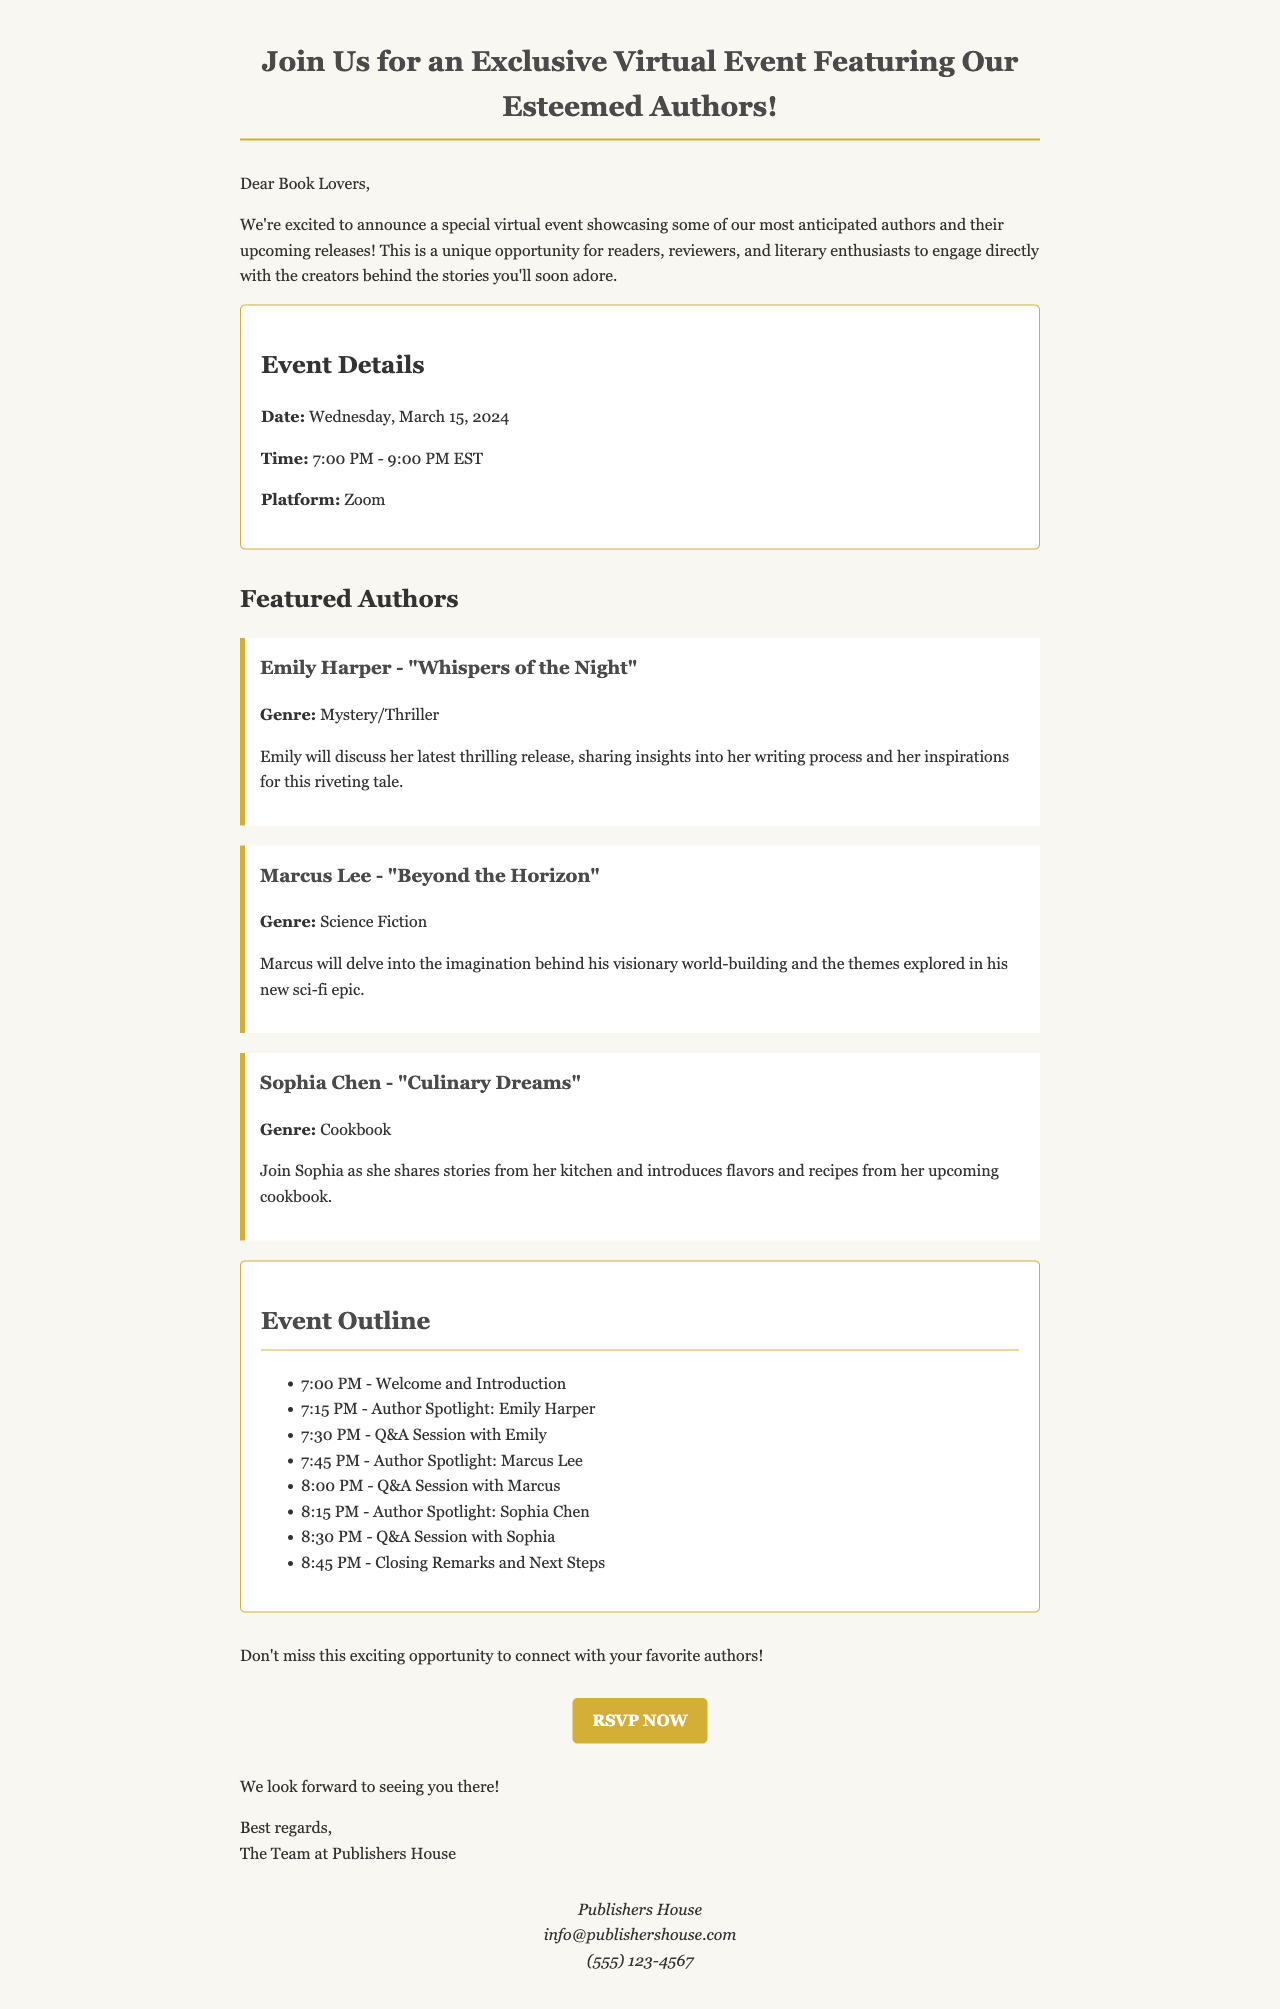What is the date of the event? The date of the event is mentioned in the Event Details section.
Answer: March 15, 2024 What time does the event start? The start time of the event is provided in the Event Details section.
Answer: 7:00 PM What is the platform for the event? The platform to be used for the event is specified in the Event Details section.
Answer: Zoom Who is the author of "Culinary Dreams"? The author of "Culinary Dreams" is listed under the Featured Authors section.
Answer: Sophia Chen What genre does Emily Harper's book belong to? The genre of Emily Harper's book is mentioned in her author spotlight.
Answer: Mystery/Thriller What is one topic Marcus Lee will discuss? Marcus Lee's discussion topic is part of the event introduction for his author spotlight.
Answer: World-building How many Q&A sessions are scheduled during the event? The number of Q&A sessions is determined by counting the individual sessions outlined in the Event Outline.
Answer: Three What is the RSVP link provided for the event? The RSVP link is included in the Call to Action section of the email.
Answer: https://www.publishershouse.com/virtual-event-rsvp What is the main aim of the event? The aim of the event is summarized in the opening paragraph of the email.
Answer: Engage directly with authors 